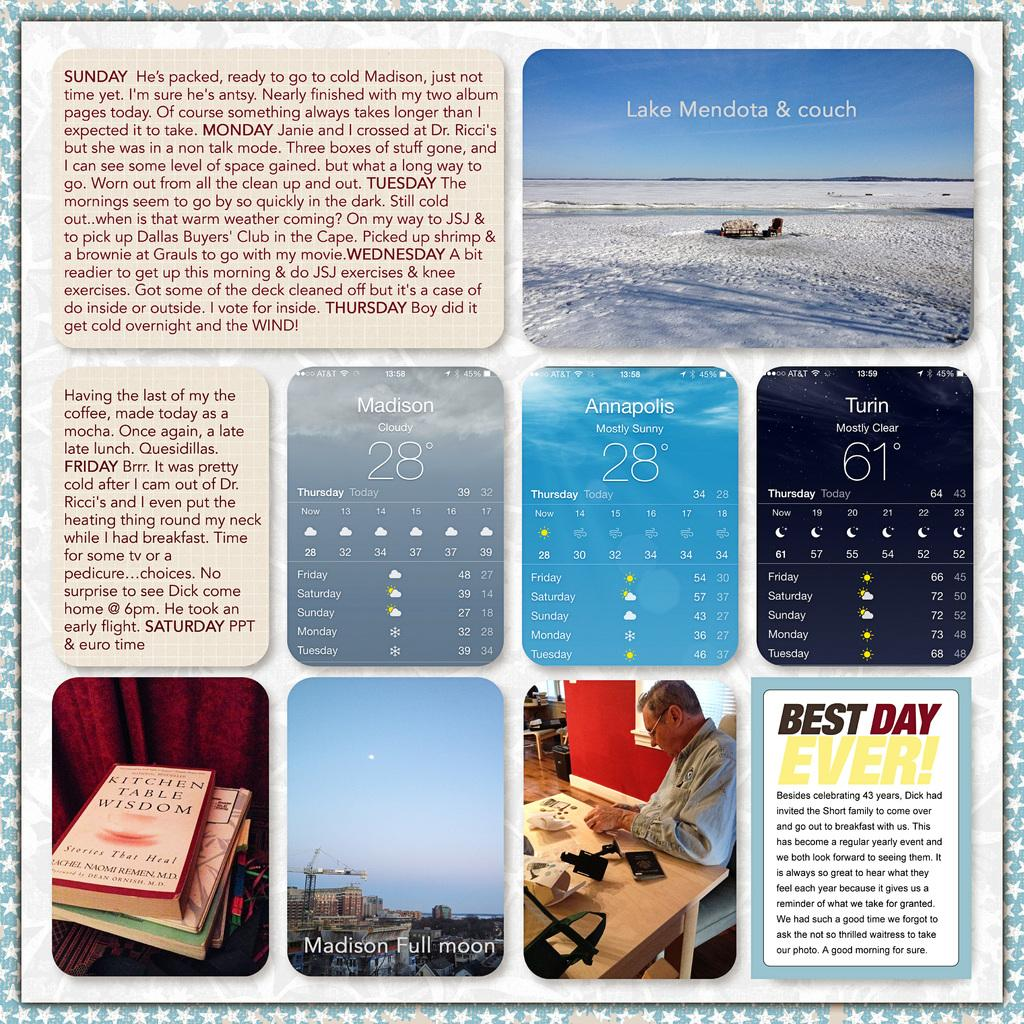<image>
Relay a brief, clear account of the picture shown. a bunch of different photos of books and weather and one that has Best Day Ever on it 